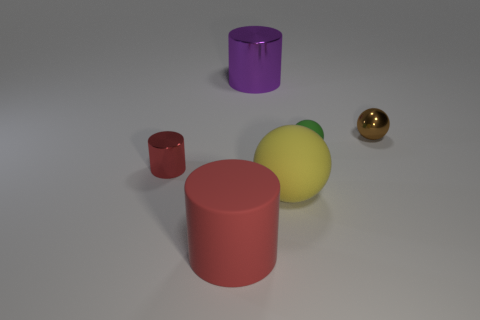Subtract all big matte spheres. How many spheres are left? 2 Subtract 2 cylinders. How many cylinders are left? 1 Add 1 tiny matte objects. How many objects exist? 7 Subtract all green spheres. How many spheres are left? 2 Subtract all cyan cylinders. Subtract all purple balls. How many cylinders are left? 3 Subtract all green blocks. How many green spheres are left? 1 Subtract all small metal things. Subtract all purple objects. How many objects are left? 3 Add 6 yellow objects. How many yellow objects are left? 7 Add 1 small metallic balls. How many small metallic balls exist? 2 Subtract 1 green balls. How many objects are left? 5 